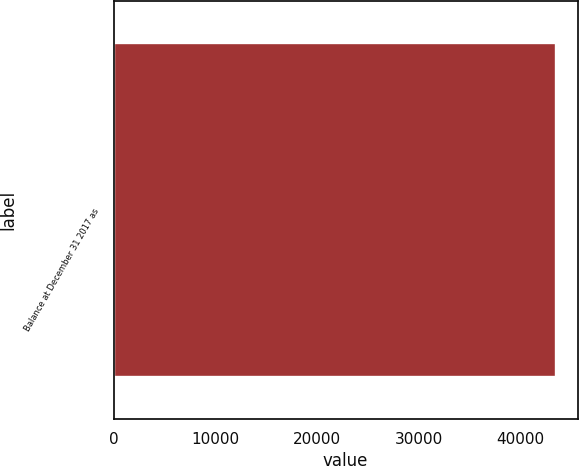<chart> <loc_0><loc_0><loc_500><loc_500><bar_chart><fcel>Balance at December 31 2017 as<nl><fcel>43454.1<nl></chart> 